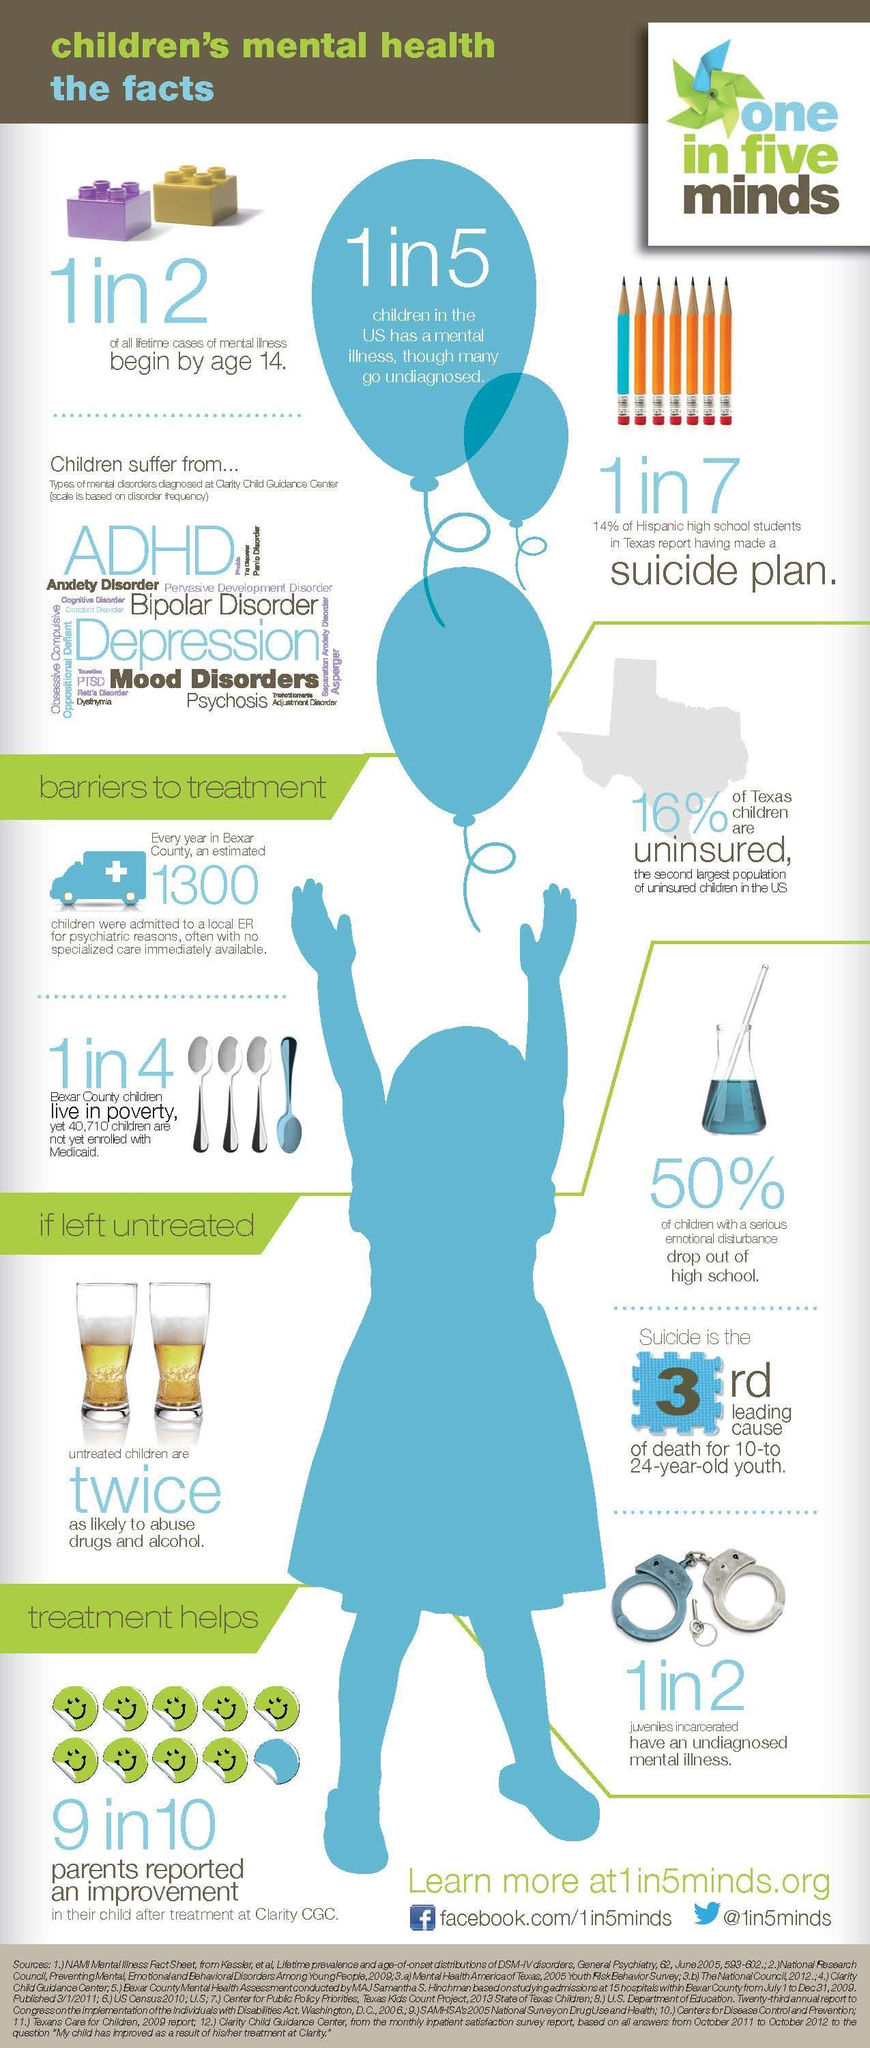What % of parents reported improvement after treatment
Answer the question with a short phrase. 90 What percentage of children in Bexar Country live in poverty 25 what percentage of all lifetime cases of mental illness begin by age 14 50 what percentage of children in US have a mental illness though many go undiagnosed 20 What are the 2 main mental disorders that children suffer from ADHD, Depression Where is the second largest population of uninsured children in US Texas 